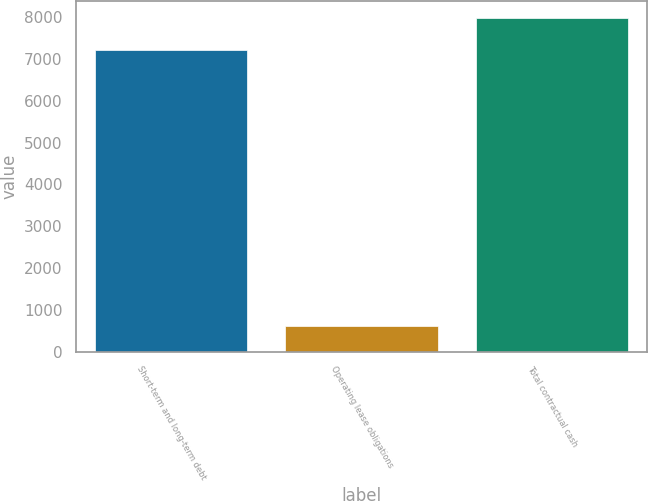Convert chart to OTSL. <chart><loc_0><loc_0><loc_500><loc_500><bar_chart><fcel>Short-term and long-term debt<fcel>Operating lease obligations<fcel>Total contractual cash<nl><fcel>7225<fcel>612<fcel>7975<nl></chart> 